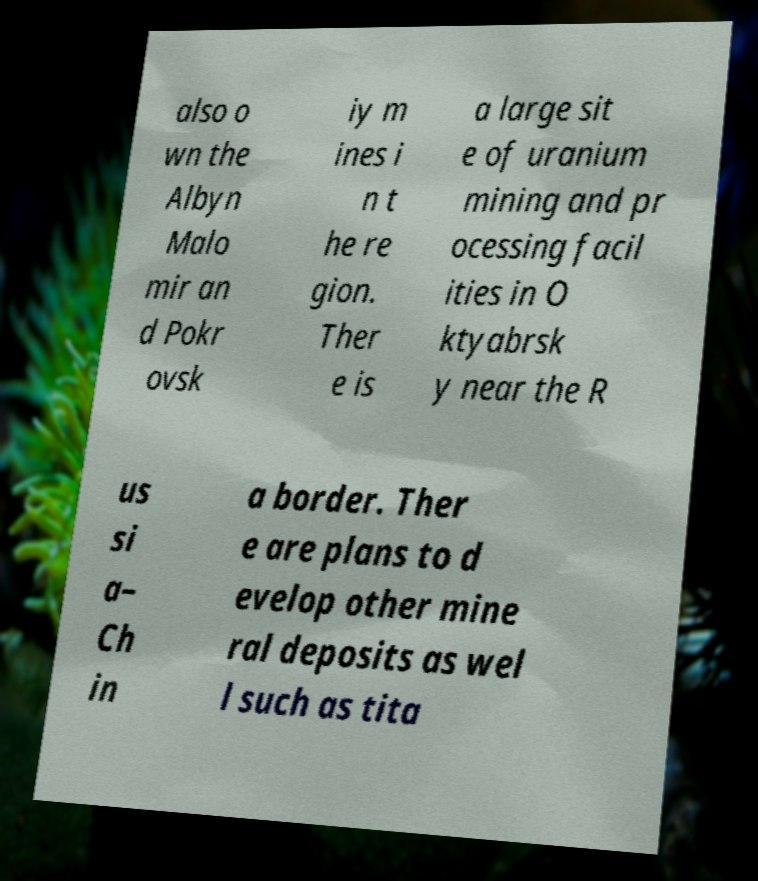Please read and relay the text visible in this image. What does it say? also o wn the Albyn Malo mir an d Pokr ovsk iy m ines i n t he re gion. Ther e is a large sit e of uranium mining and pr ocessing facil ities in O ktyabrsk y near the R us si a– Ch in a border. Ther e are plans to d evelop other mine ral deposits as wel l such as tita 